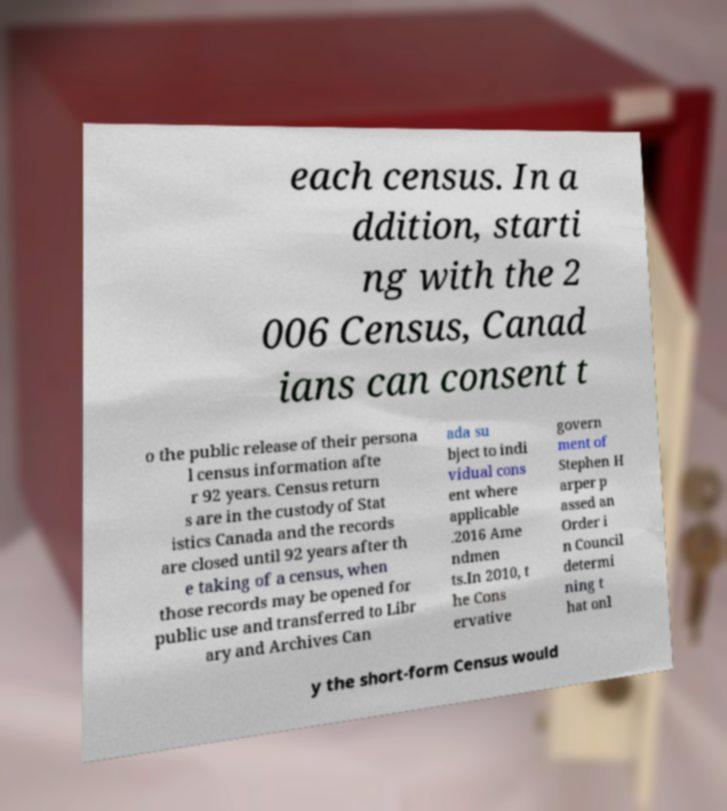Can you read and provide the text displayed in the image?This photo seems to have some interesting text. Can you extract and type it out for me? each census. In a ddition, starti ng with the 2 006 Census, Canad ians can consent t o the public release of their persona l census information afte r 92 years. Census return s are in the custody of Stat istics Canada and the records are closed until 92 years after th e taking of a census, when those records may be opened for public use and transferred to Libr ary and Archives Can ada su bject to indi vidual cons ent where applicable .2016 Ame ndmen ts.In 2010, t he Cons ervative govern ment of Stephen H arper p assed an Order i n Council determi ning t hat onl y the short-form Census would 